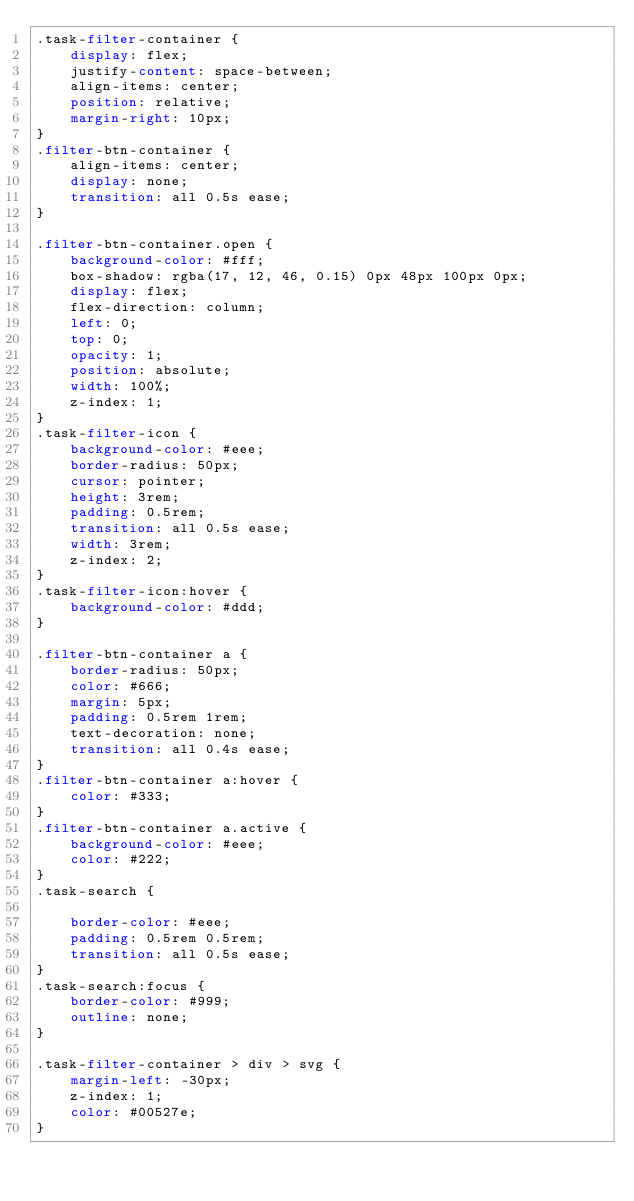<code> <loc_0><loc_0><loc_500><loc_500><_CSS_>.task-filter-container {
	display: flex;
	justify-content: space-between;
	align-items: center;
	position: relative;
	margin-right: 10px;
}
.filter-btn-container {
	align-items: center;
	display: none;
	transition: all 0.5s ease;
}

.filter-btn-container.open {
	background-color: #fff;
	box-shadow: rgba(17, 12, 46, 0.15) 0px 48px 100px 0px;
	display: flex;
	flex-direction: column;
	left: 0;
	top: 0;
	opacity: 1;
	position: absolute;
	width: 100%;
	z-index: 1;
}
.task-filter-icon {
	background-color: #eee;
	border-radius: 50px;
	cursor: pointer;
	height: 3rem;
	padding: 0.5rem;
	transition: all 0.5s ease;
	width: 3rem;
	z-index: 2;
}
.task-filter-icon:hover {
	background-color: #ddd;
}

.filter-btn-container a {
	border-radius: 50px;
	color: #666;
	margin: 5px;
	padding: 0.5rem 1rem;
	text-decoration: none;
	transition: all 0.4s ease;
}
.filter-btn-container a:hover {
	color: #333;
}
.filter-btn-container a.active {
	background-color: #eee;
	color: #222;
}
.task-search {

	border-color: #eee;
	padding: 0.5rem 0.5rem;
	transition: all 0.5s ease;
}
.task-search:focus {
	border-color: #999;
	outline: none;
}

.task-filter-container > div > svg {
	margin-left: -30px;
	z-index: 1;
	color: #00527e;
}
</code> 